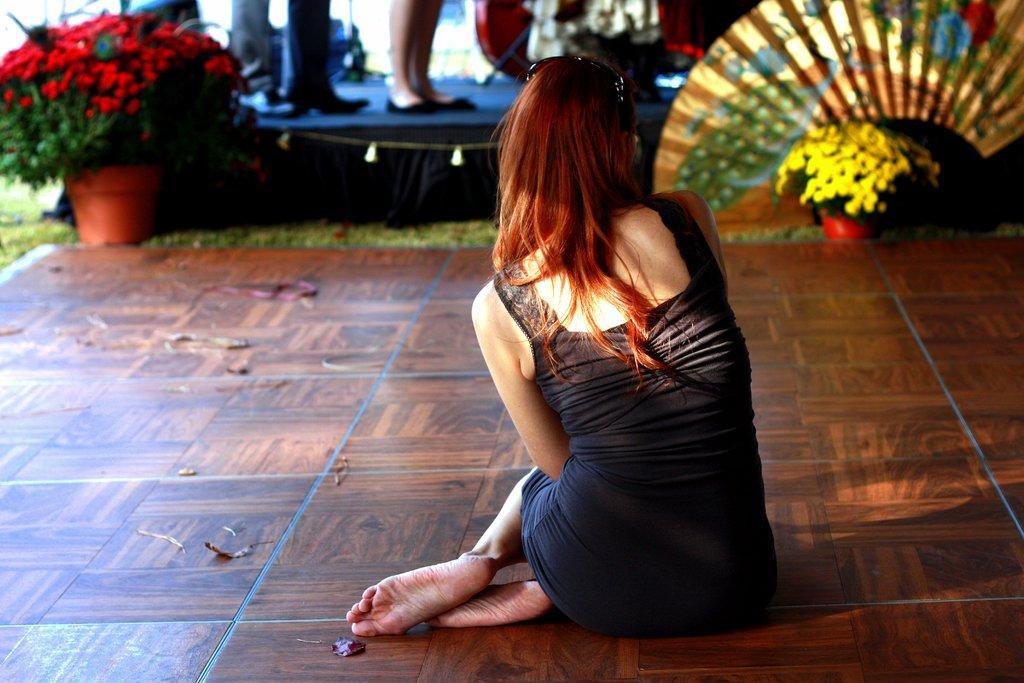Please provide a concise description of this image. In this picture I can see there is a woman wearing a black dress and sitting on the floor and there are planets arranged in the flower pots and there are few people standing on the dais. 